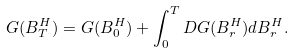<formula> <loc_0><loc_0><loc_500><loc_500>G ( B ^ { H } _ { T } ) = G ( B ^ { H } _ { 0 } ) + \int _ { 0 } ^ { T } D G ( B ^ { H } _ { r } ) d B ^ { H } _ { r } .</formula> 